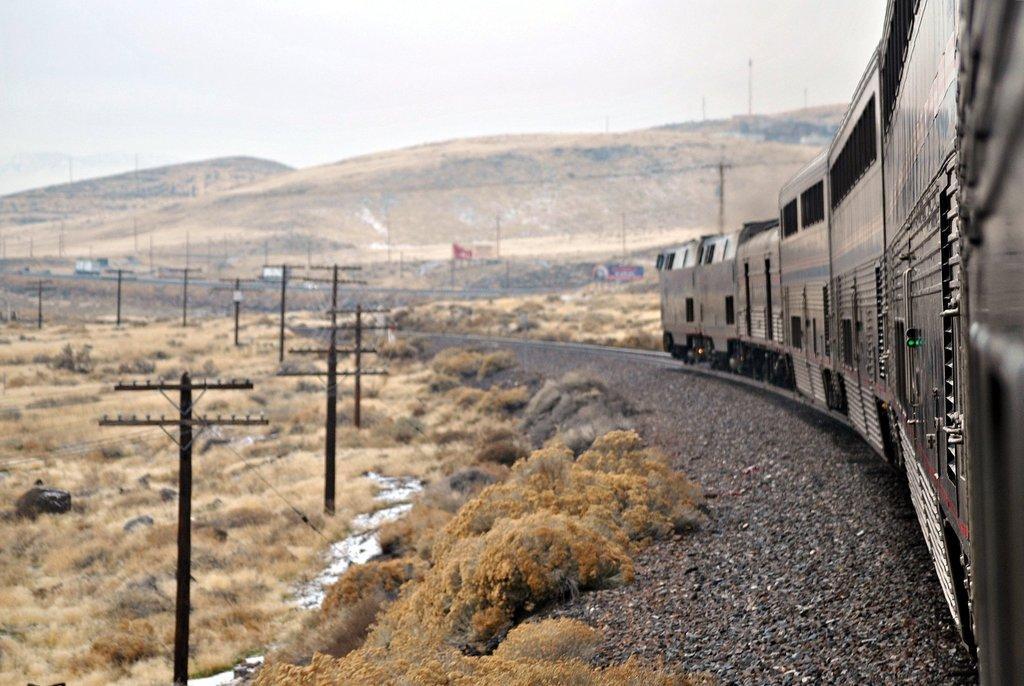Please provide a concise description of this image. In this image there is a train on the railway track. The train is taking the turn. Beside the train there are stones. At the top there is the sky. There are electric poles on the left side. At the bottom there is dry grass. 